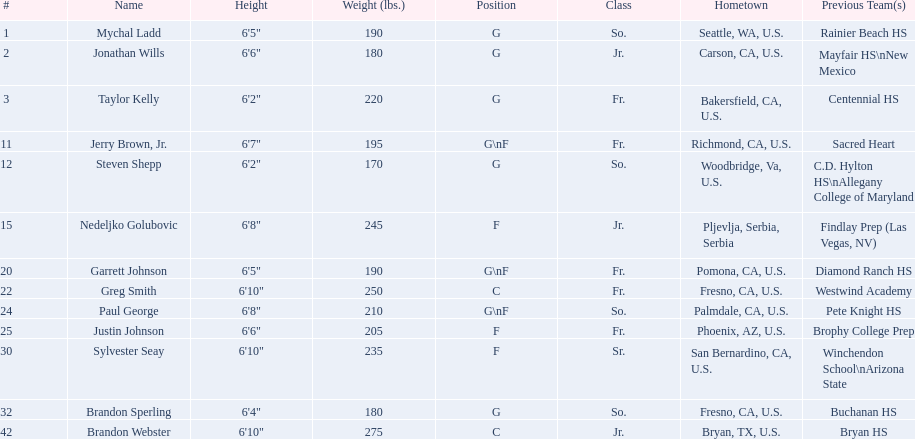What class was each team member in for the 2009-10 fresno state bulldogs? So., Jr., Fr., Fr., So., Jr., Fr., Fr., So., Fr., Sr., So., Jr. Which of these was outside of the us? Jr. Who was the player? Nedeljko Golubovic. Can you give me this table in json format? {'header': ['#', 'Name', 'Height', 'Weight (lbs.)', 'Position', 'Class', 'Hometown', 'Previous Team(s)'], 'rows': [['1', 'Mychal Ladd', '6\'5"', '190', 'G', 'So.', 'Seattle, WA, U.S.', 'Rainier Beach HS'], ['2', 'Jonathan Wills', '6\'6"', '180', 'G', 'Jr.', 'Carson, CA, U.S.', 'Mayfair HS\\nNew Mexico'], ['3', 'Taylor Kelly', '6\'2"', '220', 'G', 'Fr.', 'Bakersfield, CA, U.S.', 'Centennial HS'], ['11', 'Jerry Brown, Jr.', '6\'7"', '195', 'G\\nF', 'Fr.', 'Richmond, CA, U.S.', 'Sacred Heart'], ['12', 'Steven Shepp', '6\'2"', '170', 'G', 'So.', 'Woodbridge, Va, U.S.', 'C.D. Hylton HS\\nAllegany College of Maryland'], ['15', 'Nedeljko Golubovic', '6\'8"', '245', 'F', 'Jr.', 'Pljevlja, Serbia, Serbia', 'Findlay Prep (Las Vegas, NV)'], ['20', 'Garrett Johnson', '6\'5"', '190', 'G\\nF', 'Fr.', 'Pomona, CA, U.S.', 'Diamond Ranch HS'], ['22', 'Greg Smith', '6\'10"', '250', 'C', 'Fr.', 'Fresno, CA, U.S.', 'Westwind Academy'], ['24', 'Paul George', '6\'8"', '210', 'G\\nF', 'So.', 'Palmdale, CA, U.S.', 'Pete Knight HS'], ['25', 'Justin Johnson', '6\'6"', '205', 'F', 'Fr.', 'Phoenix, AZ, U.S.', 'Brophy College Prep'], ['30', 'Sylvester Seay', '6\'10"', '235', 'F', 'Sr.', 'San Bernardino, CA, U.S.', 'Winchendon School\\nArizona State'], ['32', 'Brandon Sperling', '6\'4"', '180', 'G', 'So.', 'Fresno, CA, U.S.', 'Buchanan HS'], ['42', 'Brandon Webster', '6\'10"', '275', 'C', 'Jr.', 'Bryan, TX, U.S.', 'Bryan HS']]} 